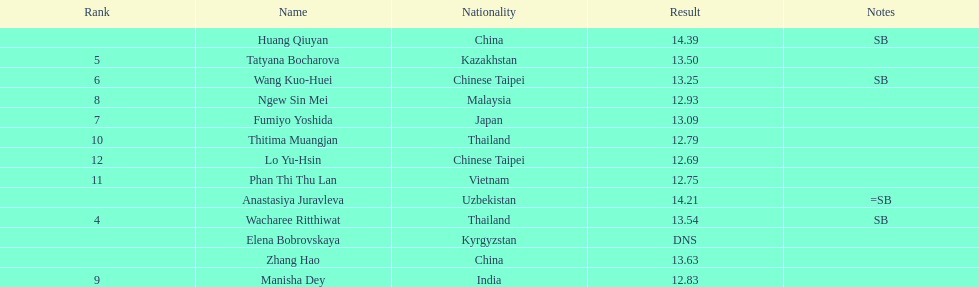How many competitors had less than 13.00 points? 6. 